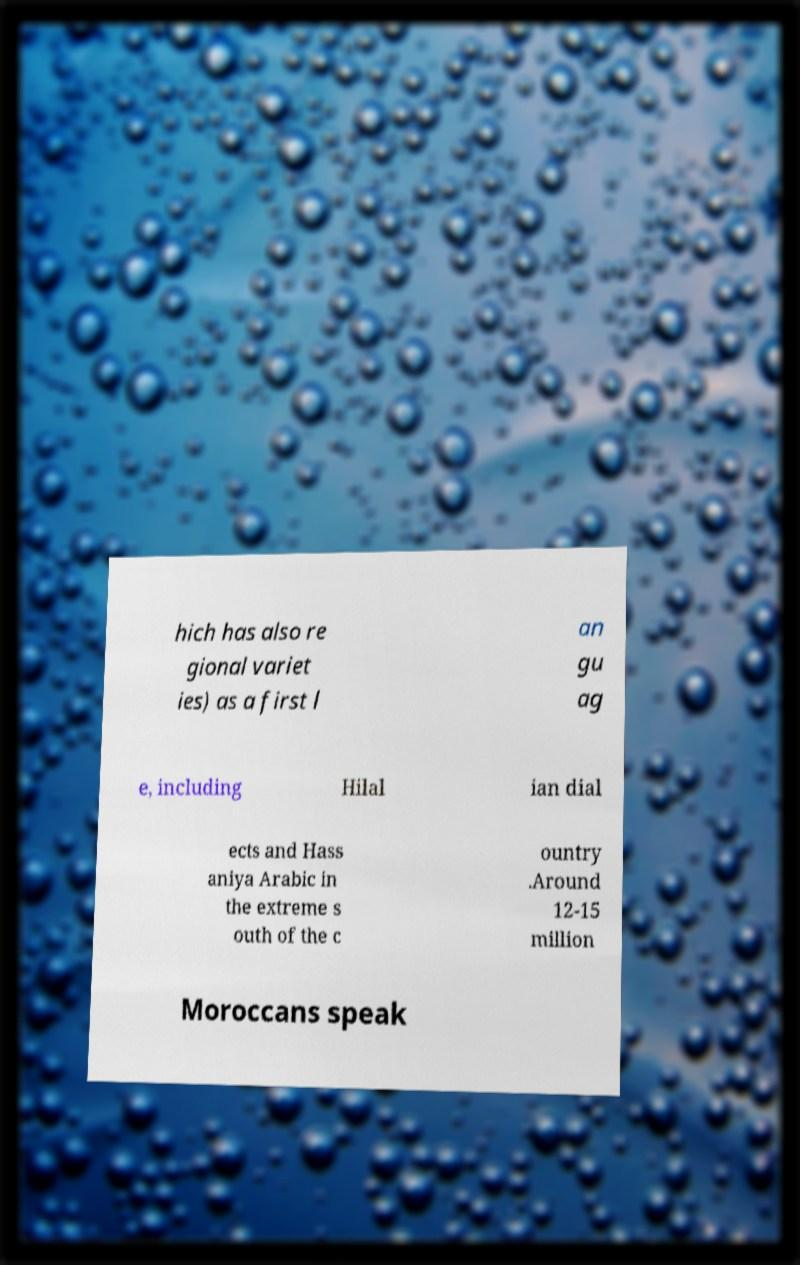What messages or text are displayed in this image? I need them in a readable, typed format. hich has also re gional variet ies) as a first l an gu ag e, including Hilal ian dial ects and Hass aniya Arabic in the extreme s outh of the c ountry .Around 12-15 million Moroccans speak 